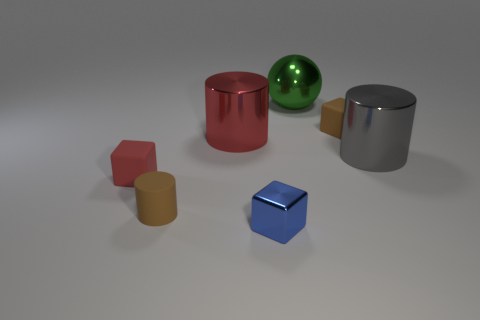Do the rubber block in front of the red metallic object and the tiny blue shiny block have the same size?
Keep it short and to the point. Yes. How many metallic things are either cubes or large cylinders?
Your answer should be compact. 3. There is a small block that is to the right of the matte cylinder and in front of the large gray shiny object; what is it made of?
Keep it short and to the point. Metal. Does the brown cylinder have the same material as the gray cylinder?
Offer a very short reply. No. How big is the metal object that is right of the blue object and in front of the small brown block?
Your answer should be compact. Large. The gray thing is what shape?
Make the answer very short. Cylinder. What number of things are green metal objects or brown rubber things that are in front of the red matte block?
Your answer should be very brief. 2. Does the cube that is behind the big gray shiny cylinder have the same color as the rubber cylinder?
Offer a terse response. Yes. What color is the small thing that is both to the left of the large red cylinder and in front of the red matte cube?
Keep it short and to the point. Brown. There is a cylinder behind the large gray shiny cylinder; what is its material?
Your response must be concise. Metal. 